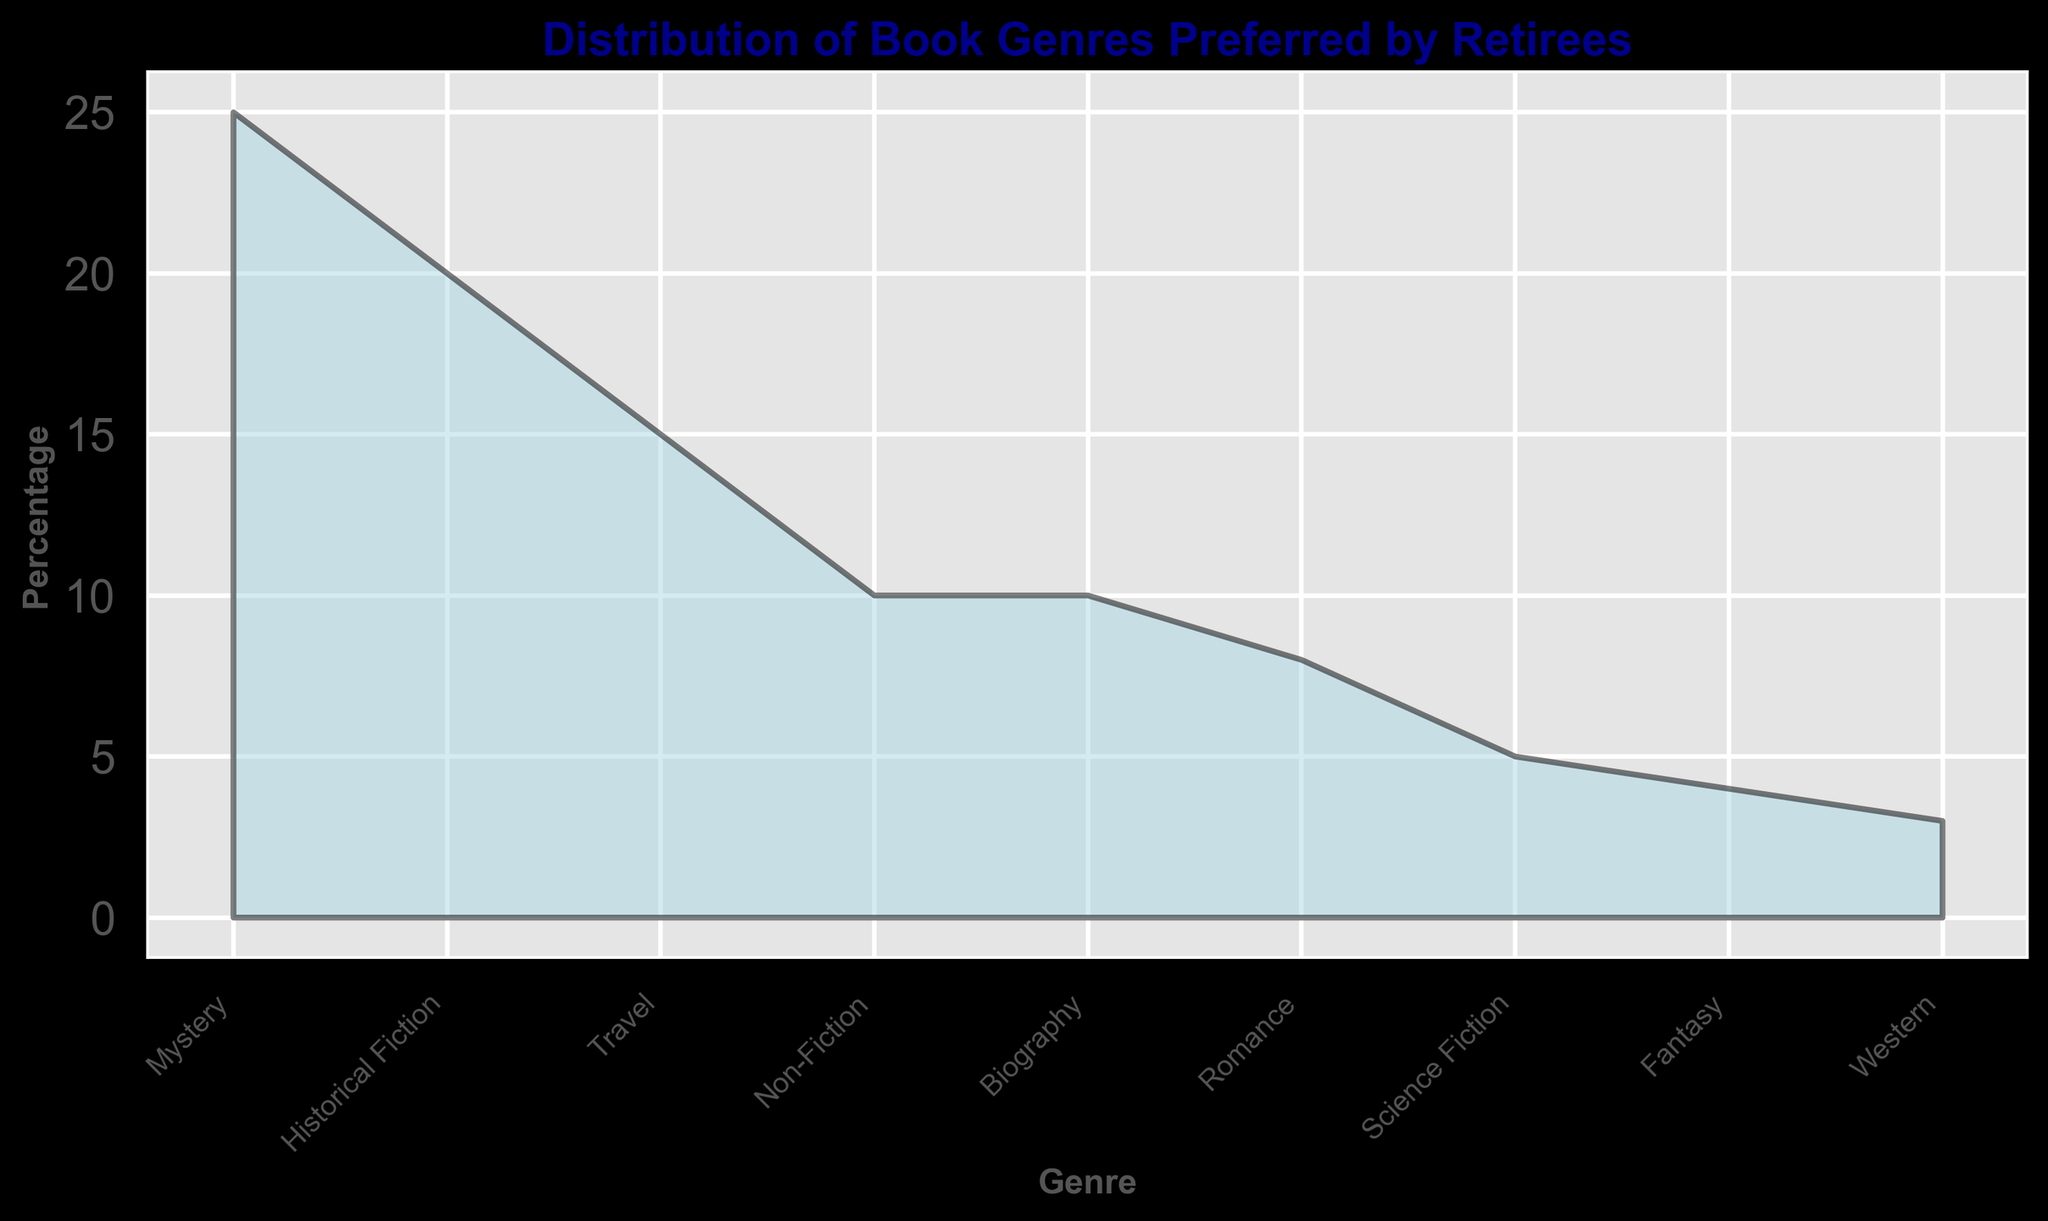What genre has the highest percentage of preference among retirees? The genre with the highest percentage would have the tallest area in the chart. The Mystery genre has the highest value, reaching 25%.
Answer: Mystery What's the total percentage of retirees who prefer either Mystery or Historical Fiction? Sum the percentages for Mystery and Historical Fiction. Mystery is 25% and Historical Fiction is 20%, so 25 + 20 = 45%.
Answer: 45% Which genre is preferred by more retirees, Romance or Science Fiction? Compare the percentages for Romance and Science Fiction. Romance has 8% while Science Fiction has 5%, so Romance is preferred more.
Answer: Romance How much more popular is the Mystery genre compared to the Fantasy genre? Subtract the percentage of Fantasy from the percentage of Mystery. Mystery is 25% and Fantasy is 4%, so 25 - 4 = 21%.
Answer: 21% What's the combined percentage of retirees who prefer Non-Fiction, Biography, and Western genres? Add the percentages of Non-Fiction, Biography, and Western. Non-Fiction is 10%, Biography is 10%, and Western is 3%. So, 10 + 10 + 3 = 23%.
Answer: 23% Does the Mystery genre have more than double the percentage of preference compared to the Travel genre? Compare the percentage of Mystery to double the percentage of Travel. Mystery is 25% and Travel is 15%. Double of 15% is 30%, and since 25 < 30, Mystery does not have more than double the preference.
Answer: No Which genre has the least percentage of preference? The genre with the smallest area or height in the chart. The Western genre, with 3%, is the lowest.
Answer: Western How many genres have a preference percentage of 10% or more? Count all the genres where the percentage is at least 10%. Mystery (25%), Historical Fiction (20%), Travel (15%), Non-Fiction (10%), and Biography (10%) make five genres.
Answer: 5 What's the average percentage of preference for Romance, Science Fiction, and Fantasy genres? Find the average of these three percentages. Romance is 8%, Science Fiction is 5%, and Fantasy is 4%. The sum is 8 + 5 + 4 = 17, and the average is 17 / 3 ≈ 5.67%.
Answer: 5.67% Are there more retirees preferring Non-Fiction compared to those preferring Western and Romance combined? Compare the percentage of Non-Fiction to the combined percentage of Western and Romance. Non-Fiction is 10%, Western is 3%, and Romance is 8%. Combined, Western and Romance are 3 + 8 = 11%, so Non-Fiction is less.
Answer: No 